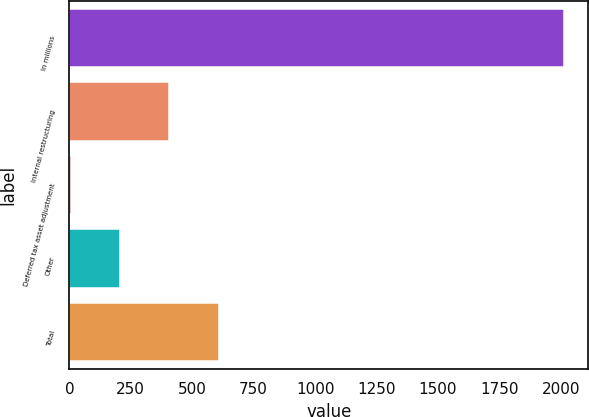<chart> <loc_0><loc_0><loc_500><loc_500><bar_chart><fcel>In millions<fcel>Internal restructuring<fcel>Deferred tax asset adjustment<fcel>Other<fcel>Total<nl><fcel>2012<fcel>406.4<fcel>5<fcel>205.7<fcel>607.1<nl></chart> 